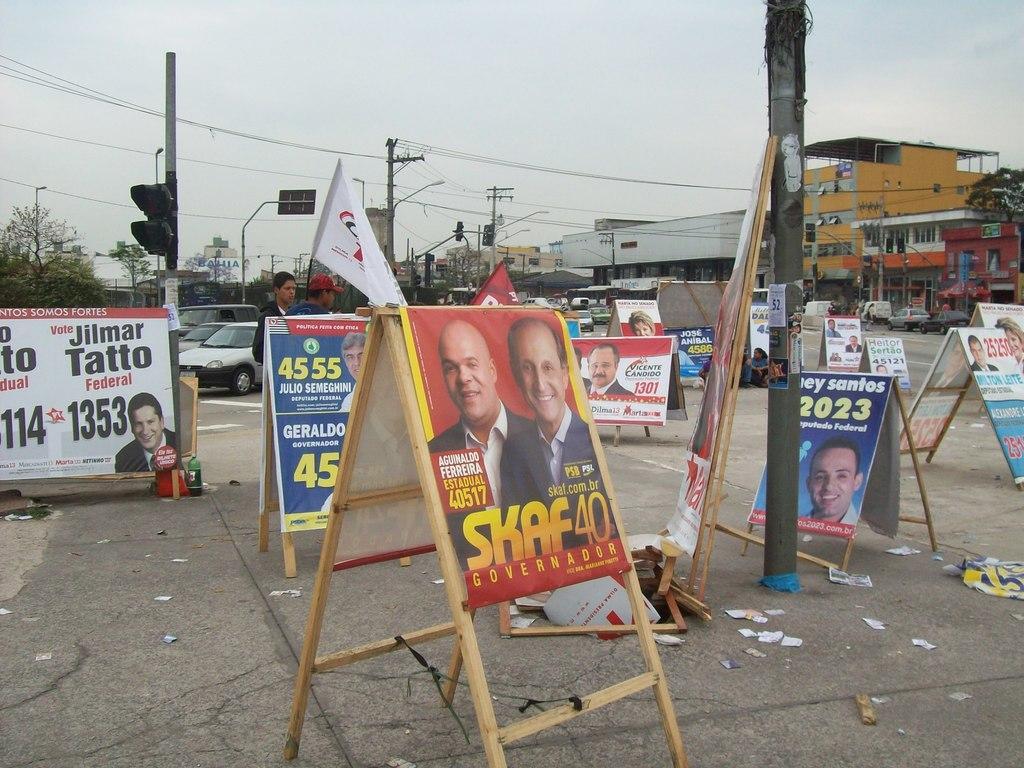Please provide a concise description of this image. In this image we can see some signage boards to which some posters are attached to it and in the background of the image there are some current polls, traffic signals, trees, buildings and clear sky. 